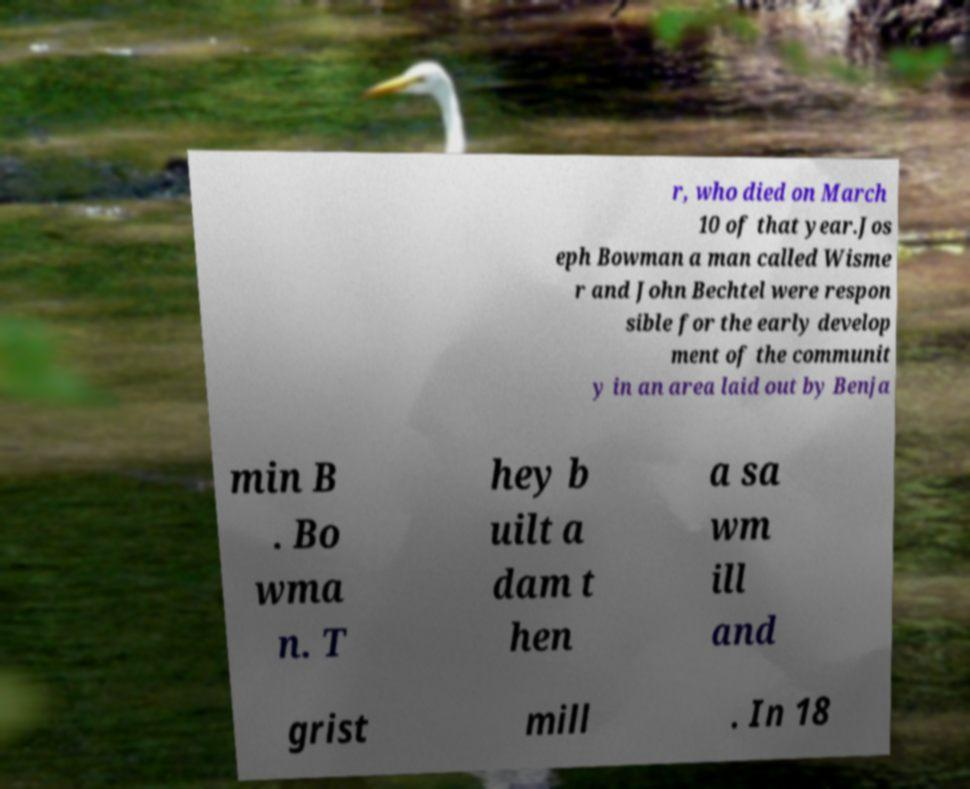Please identify and transcribe the text found in this image. r, who died on March 10 of that year.Jos eph Bowman a man called Wisme r and John Bechtel were respon sible for the early develop ment of the communit y in an area laid out by Benja min B . Bo wma n. T hey b uilt a dam t hen a sa wm ill and grist mill . In 18 